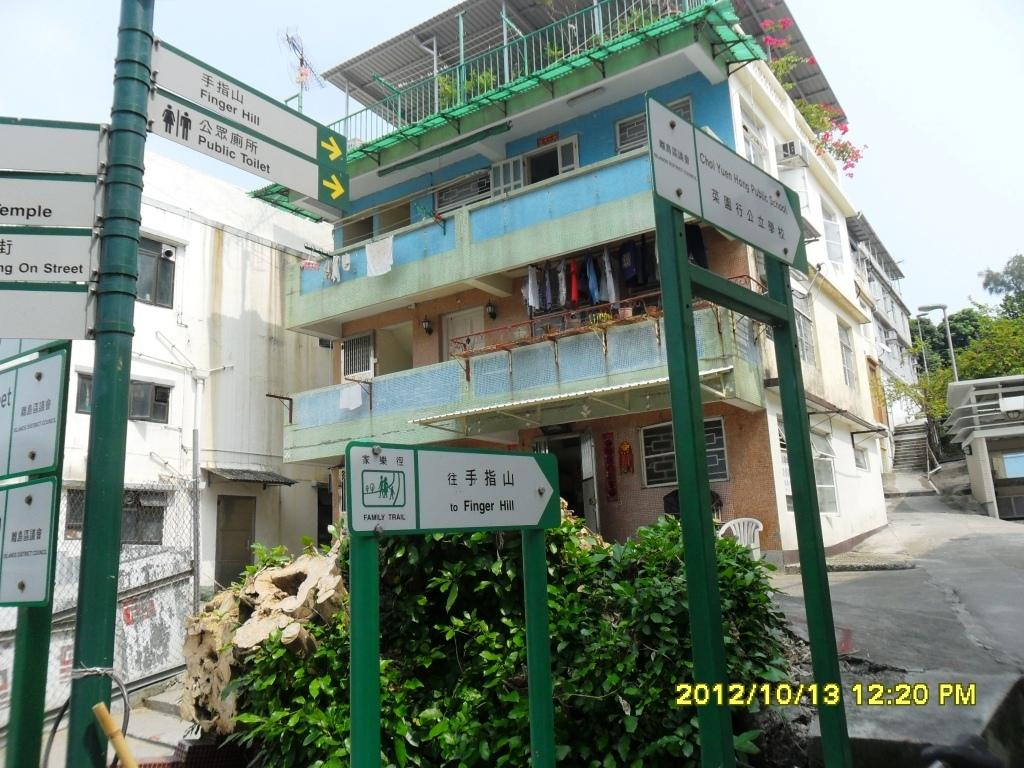What can be seen on the left side of the image? There are sign boards on poles on the left side of the image. What is located in the middle of the image? There is a plant in the middle of the image. What type of structure is on the right side of the image? There is a building on the right side of the image. What type of disease is affecting the plant in the image? There is no indication of any disease affecting the plant in the image. Can you see a stream flowing through the image? There is no stream visible in the image. 